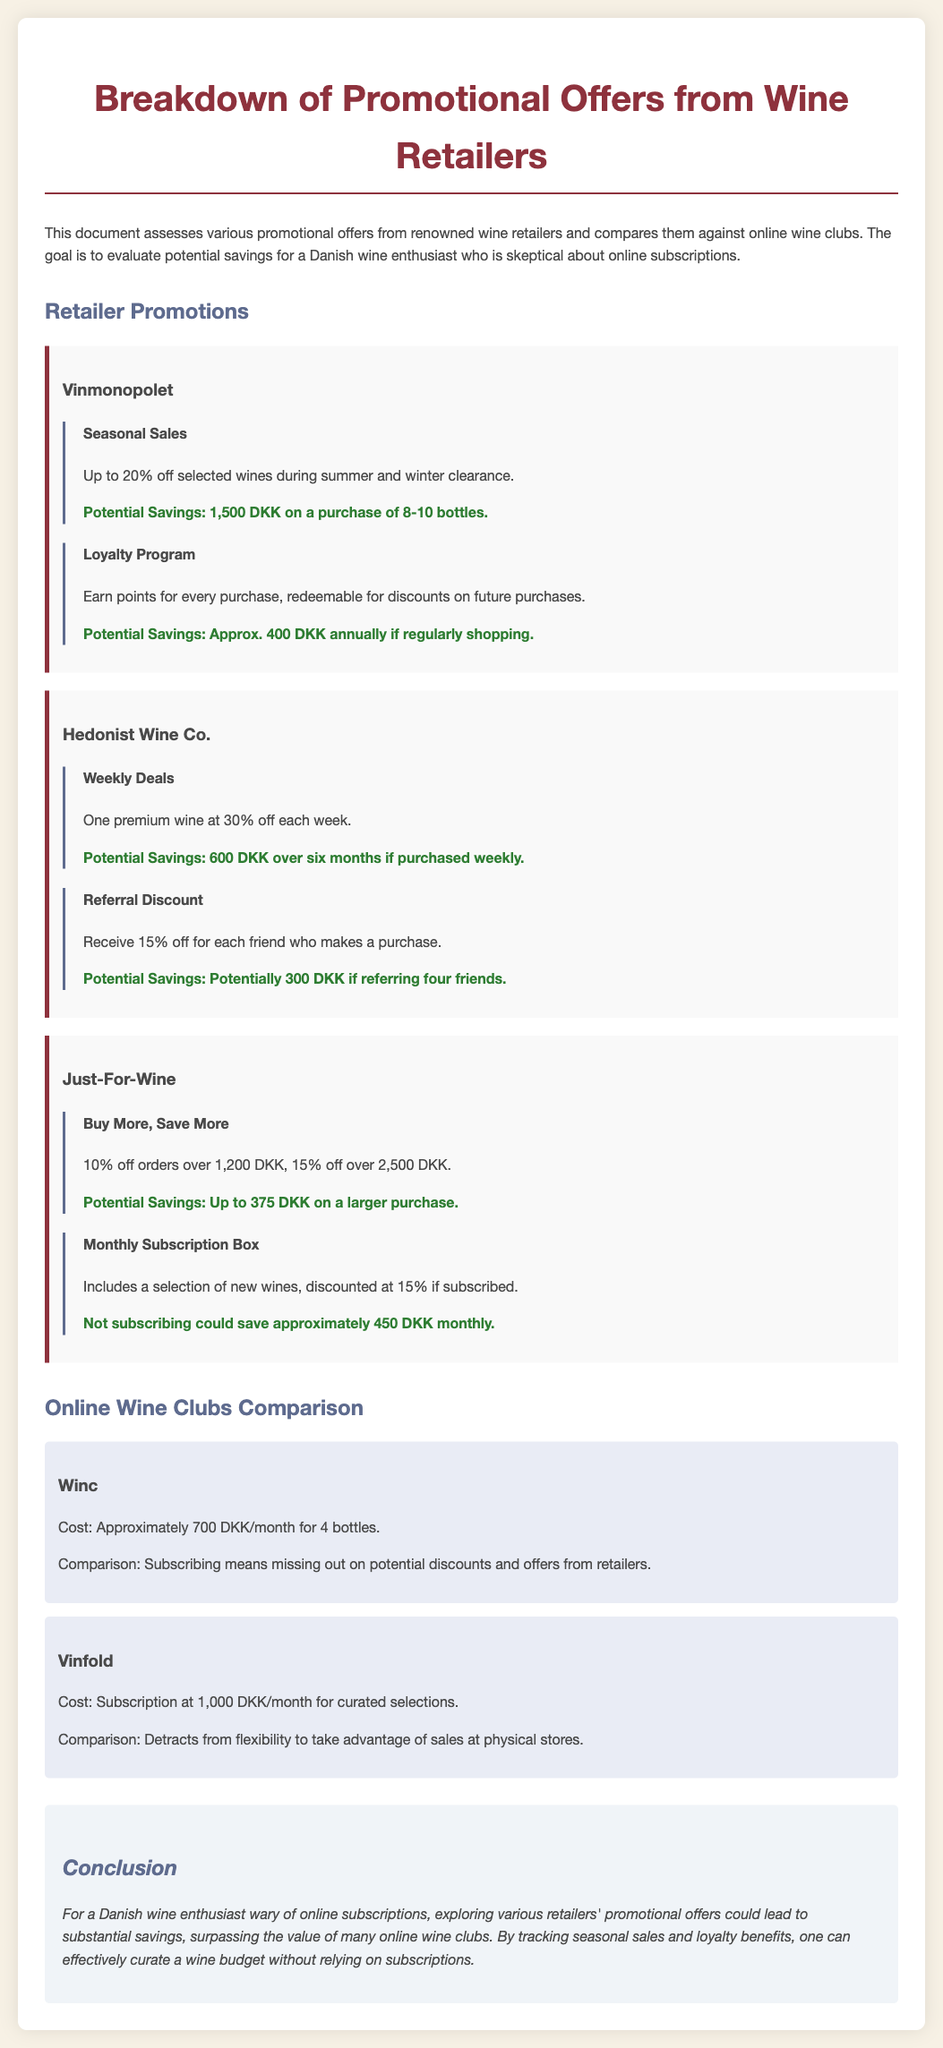What is the maximum discount offered by Vinmonopolet? The maximum discount offered by Vinmonopolet is during seasonal sales up to 20% off selected wines.
Answer: 20% How much can a customer save through the Hedonist Wine Co.'s weekly deals over six months? The potential savings from weekly deals at Hedonist Wine Co. is given as 600 DKK over six months.
Answer: 600 DKK What is the cost of a subscription to Winc? The document mentions that the cost of a subscription to Winc is approximately 700 DKK/month for 4 bottles.
Answer: 700 DKK What type of promotion does Just-For-Wine offer for larger orders? Just-For-Wine offers 10% off orders over 1,200 DKK and 15% off over 2,500 DKK.
Answer: Buy More, Save More How much could a customer potentially save by not subscribing to Just-For-Wine's monthly subscription box? The document specifies that not subscribing to Just-For-Wine's monthly subscription box could save approximately 450 DKK monthly.
Answer: 450 DKK What loyalty benefit is provided by Vinmonopolet? Vinmonopolet has a loyalty program where customers earn points for purchases redeemable for discounts on future purchases.
Answer: Loyalty Program What is the annual potential savings from Vinmonopolet's loyalty program if shopping regularly? The document states that potential annual savings from the loyalty program is approximately 400 DKK.
Answer: 400 DKK What is a downside mentioned for subscribing to Vinfold? The downside of subscribing to Vinfold is it detracts from the flexibility to take advantage of sales at physical stores.
Answer: Flexibility to take advantage of sales 